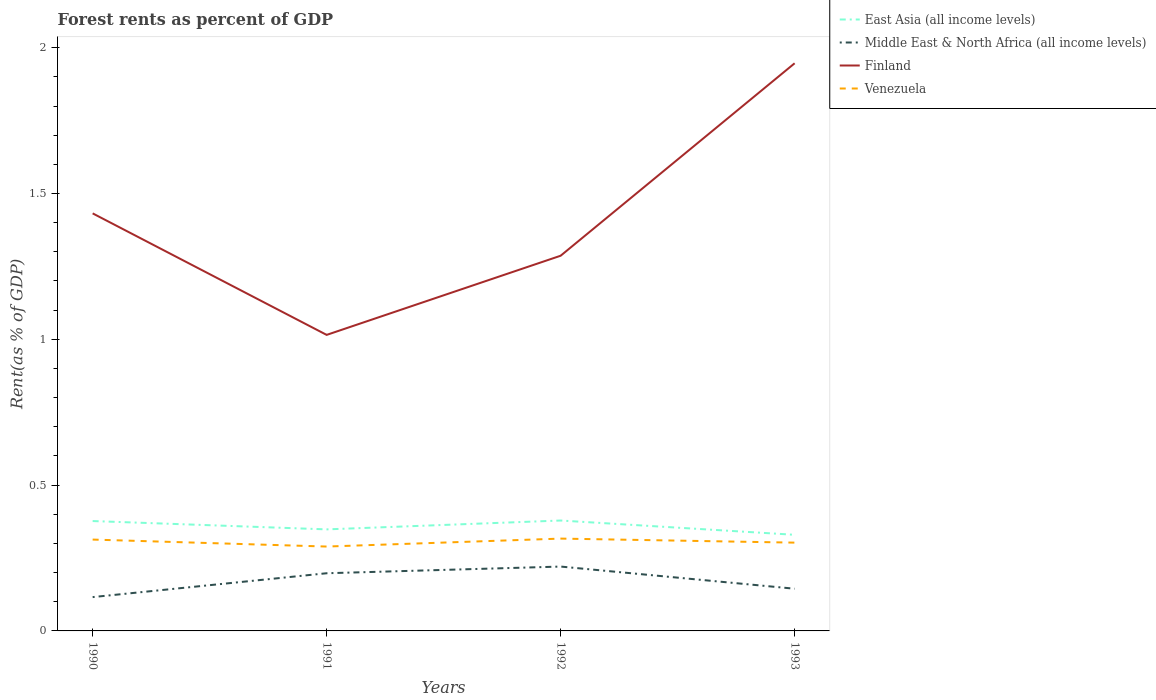How many different coloured lines are there?
Provide a short and direct response. 4. Does the line corresponding to Middle East & North Africa (all income levels) intersect with the line corresponding to Finland?
Make the answer very short. No. Is the number of lines equal to the number of legend labels?
Keep it short and to the point. Yes. Across all years, what is the maximum forest rent in Finland?
Your response must be concise. 1.02. In which year was the forest rent in Middle East & North Africa (all income levels) maximum?
Your answer should be very brief. 1990. What is the total forest rent in Middle East & North Africa (all income levels) in the graph?
Your answer should be compact. -0.03. What is the difference between the highest and the second highest forest rent in East Asia (all income levels)?
Keep it short and to the point. 0.05. What is the difference between the highest and the lowest forest rent in Finland?
Provide a short and direct response. 2. Is the forest rent in Middle East & North Africa (all income levels) strictly greater than the forest rent in East Asia (all income levels) over the years?
Your answer should be very brief. Yes. How many lines are there?
Your answer should be very brief. 4. What is the difference between two consecutive major ticks on the Y-axis?
Make the answer very short. 0.5. How many legend labels are there?
Give a very brief answer. 4. How are the legend labels stacked?
Provide a succinct answer. Vertical. What is the title of the graph?
Your answer should be compact. Forest rents as percent of GDP. What is the label or title of the Y-axis?
Your answer should be compact. Rent(as % of GDP). What is the Rent(as % of GDP) in East Asia (all income levels) in 1990?
Offer a terse response. 0.38. What is the Rent(as % of GDP) in Middle East & North Africa (all income levels) in 1990?
Provide a succinct answer. 0.12. What is the Rent(as % of GDP) of Finland in 1990?
Ensure brevity in your answer.  1.43. What is the Rent(as % of GDP) of Venezuela in 1990?
Offer a very short reply. 0.31. What is the Rent(as % of GDP) in East Asia (all income levels) in 1991?
Keep it short and to the point. 0.35. What is the Rent(as % of GDP) in Middle East & North Africa (all income levels) in 1991?
Keep it short and to the point. 0.2. What is the Rent(as % of GDP) in Finland in 1991?
Your answer should be compact. 1.02. What is the Rent(as % of GDP) in Venezuela in 1991?
Provide a succinct answer. 0.29. What is the Rent(as % of GDP) of East Asia (all income levels) in 1992?
Offer a terse response. 0.38. What is the Rent(as % of GDP) in Middle East & North Africa (all income levels) in 1992?
Ensure brevity in your answer.  0.22. What is the Rent(as % of GDP) of Finland in 1992?
Offer a terse response. 1.29. What is the Rent(as % of GDP) of Venezuela in 1992?
Provide a short and direct response. 0.32. What is the Rent(as % of GDP) in East Asia (all income levels) in 1993?
Offer a terse response. 0.33. What is the Rent(as % of GDP) of Middle East & North Africa (all income levels) in 1993?
Make the answer very short. 0.14. What is the Rent(as % of GDP) of Finland in 1993?
Your response must be concise. 1.95. What is the Rent(as % of GDP) of Venezuela in 1993?
Ensure brevity in your answer.  0.3. Across all years, what is the maximum Rent(as % of GDP) of East Asia (all income levels)?
Keep it short and to the point. 0.38. Across all years, what is the maximum Rent(as % of GDP) in Middle East & North Africa (all income levels)?
Offer a very short reply. 0.22. Across all years, what is the maximum Rent(as % of GDP) in Finland?
Offer a terse response. 1.95. Across all years, what is the maximum Rent(as % of GDP) in Venezuela?
Keep it short and to the point. 0.32. Across all years, what is the minimum Rent(as % of GDP) of East Asia (all income levels)?
Offer a very short reply. 0.33. Across all years, what is the minimum Rent(as % of GDP) of Middle East & North Africa (all income levels)?
Your answer should be very brief. 0.12. Across all years, what is the minimum Rent(as % of GDP) of Finland?
Offer a terse response. 1.02. Across all years, what is the minimum Rent(as % of GDP) of Venezuela?
Provide a succinct answer. 0.29. What is the total Rent(as % of GDP) in East Asia (all income levels) in the graph?
Offer a terse response. 1.43. What is the total Rent(as % of GDP) in Middle East & North Africa (all income levels) in the graph?
Your answer should be very brief. 0.68. What is the total Rent(as % of GDP) in Finland in the graph?
Offer a terse response. 5.68. What is the total Rent(as % of GDP) of Venezuela in the graph?
Your response must be concise. 1.22. What is the difference between the Rent(as % of GDP) in East Asia (all income levels) in 1990 and that in 1991?
Give a very brief answer. 0.03. What is the difference between the Rent(as % of GDP) in Middle East & North Africa (all income levels) in 1990 and that in 1991?
Your answer should be very brief. -0.08. What is the difference between the Rent(as % of GDP) in Finland in 1990 and that in 1991?
Provide a short and direct response. 0.42. What is the difference between the Rent(as % of GDP) of Venezuela in 1990 and that in 1991?
Ensure brevity in your answer.  0.02. What is the difference between the Rent(as % of GDP) of East Asia (all income levels) in 1990 and that in 1992?
Give a very brief answer. -0. What is the difference between the Rent(as % of GDP) in Middle East & North Africa (all income levels) in 1990 and that in 1992?
Offer a terse response. -0.1. What is the difference between the Rent(as % of GDP) in Finland in 1990 and that in 1992?
Give a very brief answer. 0.15. What is the difference between the Rent(as % of GDP) of Venezuela in 1990 and that in 1992?
Provide a short and direct response. -0. What is the difference between the Rent(as % of GDP) of East Asia (all income levels) in 1990 and that in 1993?
Offer a terse response. 0.05. What is the difference between the Rent(as % of GDP) in Middle East & North Africa (all income levels) in 1990 and that in 1993?
Your answer should be very brief. -0.03. What is the difference between the Rent(as % of GDP) in Finland in 1990 and that in 1993?
Your answer should be very brief. -0.51. What is the difference between the Rent(as % of GDP) of Venezuela in 1990 and that in 1993?
Give a very brief answer. 0.01. What is the difference between the Rent(as % of GDP) in East Asia (all income levels) in 1991 and that in 1992?
Offer a very short reply. -0.03. What is the difference between the Rent(as % of GDP) of Middle East & North Africa (all income levels) in 1991 and that in 1992?
Your answer should be compact. -0.02. What is the difference between the Rent(as % of GDP) in Finland in 1991 and that in 1992?
Offer a terse response. -0.27. What is the difference between the Rent(as % of GDP) of Venezuela in 1991 and that in 1992?
Provide a short and direct response. -0.03. What is the difference between the Rent(as % of GDP) in East Asia (all income levels) in 1991 and that in 1993?
Make the answer very short. 0.02. What is the difference between the Rent(as % of GDP) of Middle East & North Africa (all income levels) in 1991 and that in 1993?
Offer a very short reply. 0.05. What is the difference between the Rent(as % of GDP) of Finland in 1991 and that in 1993?
Offer a terse response. -0.93. What is the difference between the Rent(as % of GDP) in Venezuela in 1991 and that in 1993?
Offer a very short reply. -0.01. What is the difference between the Rent(as % of GDP) of East Asia (all income levels) in 1992 and that in 1993?
Your answer should be compact. 0.05. What is the difference between the Rent(as % of GDP) of Middle East & North Africa (all income levels) in 1992 and that in 1993?
Your response must be concise. 0.08. What is the difference between the Rent(as % of GDP) of Finland in 1992 and that in 1993?
Keep it short and to the point. -0.66. What is the difference between the Rent(as % of GDP) in Venezuela in 1992 and that in 1993?
Provide a succinct answer. 0.01. What is the difference between the Rent(as % of GDP) of East Asia (all income levels) in 1990 and the Rent(as % of GDP) of Middle East & North Africa (all income levels) in 1991?
Provide a succinct answer. 0.18. What is the difference between the Rent(as % of GDP) in East Asia (all income levels) in 1990 and the Rent(as % of GDP) in Finland in 1991?
Ensure brevity in your answer.  -0.64. What is the difference between the Rent(as % of GDP) of East Asia (all income levels) in 1990 and the Rent(as % of GDP) of Venezuela in 1991?
Make the answer very short. 0.09. What is the difference between the Rent(as % of GDP) in Middle East & North Africa (all income levels) in 1990 and the Rent(as % of GDP) in Finland in 1991?
Your answer should be very brief. -0.9. What is the difference between the Rent(as % of GDP) in Middle East & North Africa (all income levels) in 1990 and the Rent(as % of GDP) in Venezuela in 1991?
Make the answer very short. -0.17. What is the difference between the Rent(as % of GDP) in Finland in 1990 and the Rent(as % of GDP) in Venezuela in 1991?
Make the answer very short. 1.14. What is the difference between the Rent(as % of GDP) in East Asia (all income levels) in 1990 and the Rent(as % of GDP) in Middle East & North Africa (all income levels) in 1992?
Offer a very short reply. 0.16. What is the difference between the Rent(as % of GDP) in East Asia (all income levels) in 1990 and the Rent(as % of GDP) in Finland in 1992?
Give a very brief answer. -0.91. What is the difference between the Rent(as % of GDP) of East Asia (all income levels) in 1990 and the Rent(as % of GDP) of Venezuela in 1992?
Provide a succinct answer. 0.06. What is the difference between the Rent(as % of GDP) in Middle East & North Africa (all income levels) in 1990 and the Rent(as % of GDP) in Finland in 1992?
Keep it short and to the point. -1.17. What is the difference between the Rent(as % of GDP) of Middle East & North Africa (all income levels) in 1990 and the Rent(as % of GDP) of Venezuela in 1992?
Make the answer very short. -0.2. What is the difference between the Rent(as % of GDP) of Finland in 1990 and the Rent(as % of GDP) of Venezuela in 1992?
Offer a terse response. 1.12. What is the difference between the Rent(as % of GDP) in East Asia (all income levels) in 1990 and the Rent(as % of GDP) in Middle East & North Africa (all income levels) in 1993?
Keep it short and to the point. 0.23. What is the difference between the Rent(as % of GDP) of East Asia (all income levels) in 1990 and the Rent(as % of GDP) of Finland in 1993?
Make the answer very short. -1.57. What is the difference between the Rent(as % of GDP) in East Asia (all income levels) in 1990 and the Rent(as % of GDP) in Venezuela in 1993?
Provide a succinct answer. 0.07. What is the difference between the Rent(as % of GDP) in Middle East & North Africa (all income levels) in 1990 and the Rent(as % of GDP) in Finland in 1993?
Ensure brevity in your answer.  -1.83. What is the difference between the Rent(as % of GDP) in Middle East & North Africa (all income levels) in 1990 and the Rent(as % of GDP) in Venezuela in 1993?
Make the answer very short. -0.19. What is the difference between the Rent(as % of GDP) in Finland in 1990 and the Rent(as % of GDP) in Venezuela in 1993?
Ensure brevity in your answer.  1.13. What is the difference between the Rent(as % of GDP) in East Asia (all income levels) in 1991 and the Rent(as % of GDP) in Middle East & North Africa (all income levels) in 1992?
Your answer should be very brief. 0.13. What is the difference between the Rent(as % of GDP) of East Asia (all income levels) in 1991 and the Rent(as % of GDP) of Finland in 1992?
Your answer should be very brief. -0.94. What is the difference between the Rent(as % of GDP) in East Asia (all income levels) in 1991 and the Rent(as % of GDP) in Venezuela in 1992?
Your response must be concise. 0.03. What is the difference between the Rent(as % of GDP) in Middle East & North Africa (all income levels) in 1991 and the Rent(as % of GDP) in Finland in 1992?
Your answer should be compact. -1.09. What is the difference between the Rent(as % of GDP) in Middle East & North Africa (all income levels) in 1991 and the Rent(as % of GDP) in Venezuela in 1992?
Provide a succinct answer. -0.12. What is the difference between the Rent(as % of GDP) of Finland in 1991 and the Rent(as % of GDP) of Venezuela in 1992?
Ensure brevity in your answer.  0.7. What is the difference between the Rent(as % of GDP) of East Asia (all income levels) in 1991 and the Rent(as % of GDP) of Middle East & North Africa (all income levels) in 1993?
Keep it short and to the point. 0.2. What is the difference between the Rent(as % of GDP) of East Asia (all income levels) in 1991 and the Rent(as % of GDP) of Finland in 1993?
Offer a very short reply. -1.6. What is the difference between the Rent(as % of GDP) of East Asia (all income levels) in 1991 and the Rent(as % of GDP) of Venezuela in 1993?
Provide a short and direct response. 0.05. What is the difference between the Rent(as % of GDP) in Middle East & North Africa (all income levels) in 1991 and the Rent(as % of GDP) in Finland in 1993?
Your answer should be very brief. -1.75. What is the difference between the Rent(as % of GDP) of Middle East & North Africa (all income levels) in 1991 and the Rent(as % of GDP) of Venezuela in 1993?
Provide a succinct answer. -0.1. What is the difference between the Rent(as % of GDP) in Finland in 1991 and the Rent(as % of GDP) in Venezuela in 1993?
Make the answer very short. 0.71. What is the difference between the Rent(as % of GDP) in East Asia (all income levels) in 1992 and the Rent(as % of GDP) in Middle East & North Africa (all income levels) in 1993?
Ensure brevity in your answer.  0.23. What is the difference between the Rent(as % of GDP) in East Asia (all income levels) in 1992 and the Rent(as % of GDP) in Finland in 1993?
Your answer should be compact. -1.57. What is the difference between the Rent(as % of GDP) in East Asia (all income levels) in 1992 and the Rent(as % of GDP) in Venezuela in 1993?
Keep it short and to the point. 0.08. What is the difference between the Rent(as % of GDP) of Middle East & North Africa (all income levels) in 1992 and the Rent(as % of GDP) of Finland in 1993?
Offer a very short reply. -1.73. What is the difference between the Rent(as % of GDP) of Middle East & North Africa (all income levels) in 1992 and the Rent(as % of GDP) of Venezuela in 1993?
Give a very brief answer. -0.08. What is the difference between the Rent(as % of GDP) in Finland in 1992 and the Rent(as % of GDP) in Venezuela in 1993?
Give a very brief answer. 0.98. What is the average Rent(as % of GDP) of East Asia (all income levels) per year?
Offer a very short reply. 0.36. What is the average Rent(as % of GDP) of Middle East & North Africa (all income levels) per year?
Your answer should be compact. 0.17. What is the average Rent(as % of GDP) of Finland per year?
Give a very brief answer. 1.42. What is the average Rent(as % of GDP) of Venezuela per year?
Provide a succinct answer. 0.31. In the year 1990, what is the difference between the Rent(as % of GDP) of East Asia (all income levels) and Rent(as % of GDP) of Middle East & North Africa (all income levels)?
Give a very brief answer. 0.26. In the year 1990, what is the difference between the Rent(as % of GDP) of East Asia (all income levels) and Rent(as % of GDP) of Finland?
Offer a terse response. -1.06. In the year 1990, what is the difference between the Rent(as % of GDP) in East Asia (all income levels) and Rent(as % of GDP) in Venezuela?
Your response must be concise. 0.06. In the year 1990, what is the difference between the Rent(as % of GDP) in Middle East & North Africa (all income levels) and Rent(as % of GDP) in Finland?
Provide a short and direct response. -1.32. In the year 1990, what is the difference between the Rent(as % of GDP) of Middle East & North Africa (all income levels) and Rent(as % of GDP) of Venezuela?
Give a very brief answer. -0.2. In the year 1990, what is the difference between the Rent(as % of GDP) of Finland and Rent(as % of GDP) of Venezuela?
Give a very brief answer. 1.12. In the year 1991, what is the difference between the Rent(as % of GDP) in East Asia (all income levels) and Rent(as % of GDP) in Middle East & North Africa (all income levels)?
Provide a succinct answer. 0.15. In the year 1991, what is the difference between the Rent(as % of GDP) in East Asia (all income levels) and Rent(as % of GDP) in Finland?
Offer a very short reply. -0.67. In the year 1991, what is the difference between the Rent(as % of GDP) of East Asia (all income levels) and Rent(as % of GDP) of Venezuela?
Ensure brevity in your answer.  0.06. In the year 1991, what is the difference between the Rent(as % of GDP) in Middle East & North Africa (all income levels) and Rent(as % of GDP) in Finland?
Make the answer very short. -0.82. In the year 1991, what is the difference between the Rent(as % of GDP) in Middle East & North Africa (all income levels) and Rent(as % of GDP) in Venezuela?
Provide a succinct answer. -0.09. In the year 1991, what is the difference between the Rent(as % of GDP) in Finland and Rent(as % of GDP) in Venezuela?
Your answer should be compact. 0.73. In the year 1992, what is the difference between the Rent(as % of GDP) of East Asia (all income levels) and Rent(as % of GDP) of Middle East & North Africa (all income levels)?
Provide a short and direct response. 0.16. In the year 1992, what is the difference between the Rent(as % of GDP) in East Asia (all income levels) and Rent(as % of GDP) in Finland?
Make the answer very short. -0.91. In the year 1992, what is the difference between the Rent(as % of GDP) in East Asia (all income levels) and Rent(as % of GDP) in Venezuela?
Offer a terse response. 0.06. In the year 1992, what is the difference between the Rent(as % of GDP) in Middle East & North Africa (all income levels) and Rent(as % of GDP) in Finland?
Your answer should be compact. -1.07. In the year 1992, what is the difference between the Rent(as % of GDP) of Middle East & North Africa (all income levels) and Rent(as % of GDP) of Venezuela?
Offer a terse response. -0.1. In the year 1992, what is the difference between the Rent(as % of GDP) in Finland and Rent(as % of GDP) in Venezuela?
Give a very brief answer. 0.97. In the year 1993, what is the difference between the Rent(as % of GDP) of East Asia (all income levels) and Rent(as % of GDP) of Middle East & North Africa (all income levels)?
Your response must be concise. 0.18. In the year 1993, what is the difference between the Rent(as % of GDP) of East Asia (all income levels) and Rent(as % of GDP) of Finland?
Provide a short and direct response. -1.62. In the year 1993, what is the difference between the Rent(as % of GDP) in East Asia (all income levels) and Rent(as % of GDP) in Venezuela?
Make the answer very short. 0.03. In the year 1993, what is the difference between the Rent(as % of GDP) of Middle East & North Africa (all income levels) and Rent(as % of GDP) of Finland?
Offer a terse response. -1.8. In the year 1993, what is the difference between the Rent(as % of GDP) in Middle East & North Africa (all income levels) and Rent(as % of GDP) in Venezuela?
Your response must be concise. -0.16. In the year 1993, what is the difference between the Rent(as % of GDP) of Finland and Rent(as % of GDP) of Venezuela?
Give a very brief answer. 1.64. What is the ratio of the Rent(as % of GDP) of East Asia (all income levels) in 1990 to that in 1991?
Provide a short and direct response. 1.08. What is the ratio of the Rent(as % of GDP) in Middle East & North Africa (all income levels) in 1990 to that in 1991?
Keep it short and to the point. 0.59. What is the ratio of the Rent(as % of GDP) in Finland in 1990 to that in 1991?
Your answer should be very brief. 1.41. What is the ratio of the Rent(as % of GDP) in Venezuela in 1990 to that in 1991?
Your answer should be compact. 1.08. What is the ratio of the Rent(as % of GDP) of Middle East & North Africa (all income levels) in 1990 to that in 1992?
Make the answer very short. 0.53. What is the ratio of the Rent(as % of GDP) in Finland in 1990 to that in 1992?
Offer a terse response. 1.11. What is the ratio of the Rent(as % of GDP) in Venezuela in 1990 to that in 1992?
Make the answer very short. 0.99. What is the ratio of the Rent(as % of GDP) of East Asia (all income levels) in 1990 to that in 1993?
Provide a short and direct response. 1.14. What is the ratio of the Rent(as % of GDP) of Middle East & North Africa (all income levels) in 1990 to that in 1993?
Your answer should be very brief. 0.8. What is the ratio of the Rent(as % of GDP) in Finland in 1990 to that in 1993?
Make the answer very short. 0.74. What is the ratio of the Rent(as % of GDP) of Venezuela in 1990 to that in 1993?
Your answer should be compact. 1.03. What is the ratio of the Rent(as % of GDP) of East Asia (all income levels) in 1991 to that in 1992?
Your answer should be compact. 0.92. What is the ratio of the Rent(as % of GDP) of Middle East & North Africa (all income levels) in 1991 to that in 1992?
Provide a succinct answer. 0.9. What is the ratio of the Rent(as % of GDP) of Finland in 1991 to that in 1992?
Keep it short and to the point. 0.79. What is the ratio of the Rent(as % of GDP) of Venezuela in 1991 to that in 1992?
Your response must be concise. 0.91. What is the ratio of the Rent(as % of GDP) in East Asia (all income levels) in 1991 to that in 1993?
Give a very brief answer. 1.06. What is the ratio of the Rent(as % of GDP) in Middle East & North Africa (all income levels) in 1991 to that in 1993?
Offer a terse response. 1.37. What is the ratio of the Rent(as % of GDP) in Finland in 1991 to that in 1993?
Offer a very short reply. 0.52. What is the ratio of the Rent(as % of GDP) in Venezuela in 1991 to that in 1993?
Make the answer very short. 0.96. What is the ratio of the Rent(as % of GDP) of East Asia (all income levels) in 1992 to that in 1993?
Offer a very short reply. 1.15. What is the ratio of the Rent(as % of GDP) of Middle East & North Africa (all income levels) in 1992 to that in 1993?
Your answer should be compact. 1.53. What is the ratio of the Rent(as % of GDP) in Finland in 1992 to that in 1993?
Your answer should be very brief. 0.66. What is the ratio of the Rent(as % of GDP) of Venezuela in 1992 to that in 1993?
Offer a very short reply. 1.05. What is the difference between the highest and the second highest Rent(as % of GDP) of East Asia (all income levels)?
Make the answer very short. 0. What is the difference between the highest and the second highest Rent(as % of GDP) in Middle East & North Africa (all income levels)?
Make the answer very short. 0.02. What is the difference between the highest and the second highest Rent(as % of GDP) of Finland?
Your answer should be very brief. 0.51. What is the difference between the highest and the second highest Rent(as % of GDP) in Venezuela?
Make the answer very short. 0. What is the difference between the highest and the lowest Rent(as % of GDP) in East Asia (all income levels)?
Ensure brevity in your answer.  0.05. What is the difference between the highest and the lowest Rent(as % of GDP) in Middle East & North Africa (all income levels)?
Your answer should be very brief. 0.1. What is the difference between the highest and the lowest Rent(as % of GDP) in Finland?
Ensure brevity in your answer.  0.93. What is the difference between the highest and the lowest Rent(as % of GDP) of Venezuela?
Provide a short and direct response. 0.03. 